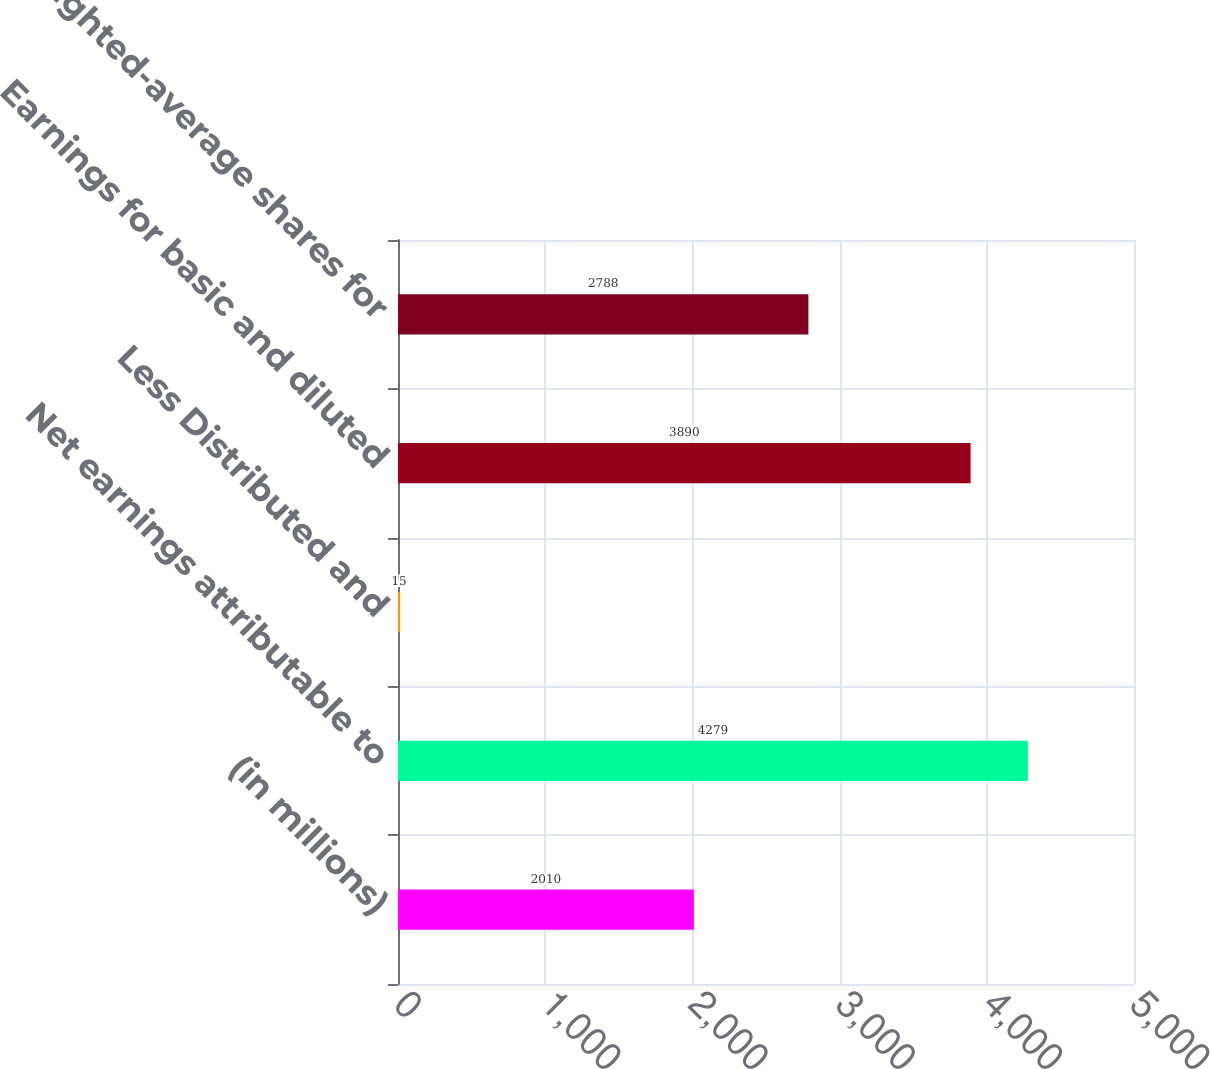Convert chart. <chart><loc_0><loc_0><loc_500><loc_500><bar_chart><fcel>(in millions)<fcel>Net earnings attributable to<fcel>Less Distributed and<fcel>Earnings for basic and diluted<fcel>Weighted-average shares for<nl><fcel>2010<fcel>4279<fcel>15<fcel>3890<fcel>2788<nl></chart> 